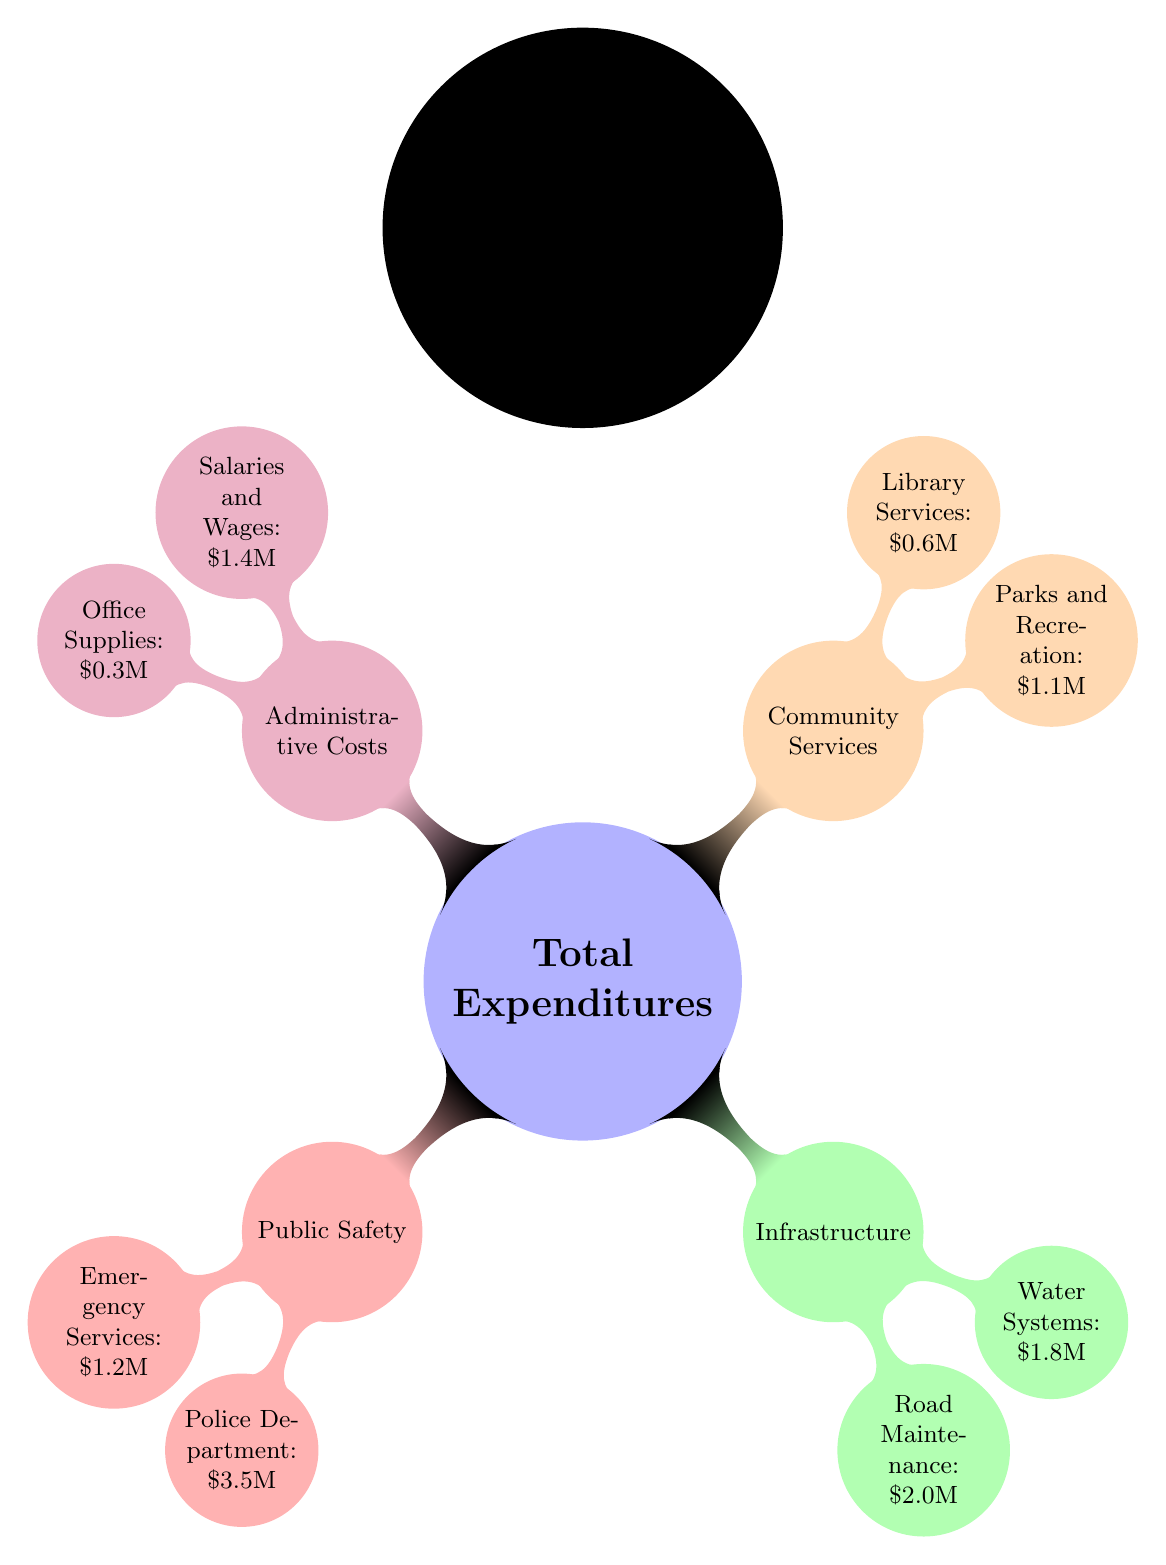What is the total expenditure amount? The diagram presents an overarching concept labeled "Total Expenditures," but does not specify an exact figure. However, you can sum the values listed in the subcategories to find the total amount.
Answer: \$11.9M Which category has the lowest expenditure? To determine this, we need to compare all the specified amounts under each category. The "Library Services" within the "Community Services" category has the lowest amount of \$0.6M.
Answer: Library Services How much is spent on Public Safety? The Public Safety category has two components: Emergency Services totaling \$1.2M and the Police Department totaling \$3.5M. Adding these values yields the total expenditure for Public Safety.
Answer: \$4.7M Which category has the highest expenditure? By analyzing all the categories and their respective expenditures, Public Safety totals \$4.7M and is highlighted as the highest amount compared to the other categories listed in the diagram.
Answer: Public Safety What percentage of the total expenditures is allocated to Infrastructure? To find the percentage, we need both the total expenditures and the amount for the Infrastructure category, which is \$3.8M. The total is \$11.9M; hence, the calculation is (3.8M / 11.9M) * 100.
Answer: 31.9% What is the expenditure for Road Maintenance compared to Water Systems? The expenditures listed for these two elements are \$2.0M for Road Maintenance and \$1.8M for Water Systems. Comparing these values indicates that Road Maintenance is higher than Water Systems by calculating the difference of \$2.0M - \$1.8M.
Answer: Road Maintenance is higher by \$0.2M How are the categories of expenditures structured in the diagram? The diagram is structured in a hierarchy where the main node is Total Expenditures, branching into four categories: Public Safety, Infrastructure, Community Services, and Administrative Costs. Each of these categories further breaks down into specific expense items.
Answer: Hierarchical structure of categories What is the total spent on Community Services? To find the total for Community Services, add the amounts allocated to Parks and Recreation (\$1.1M) and Library Services (\$0.6M). The sum of these values will reflect the total expenditure allocated to Community Services.
Answer: \$1.7M 